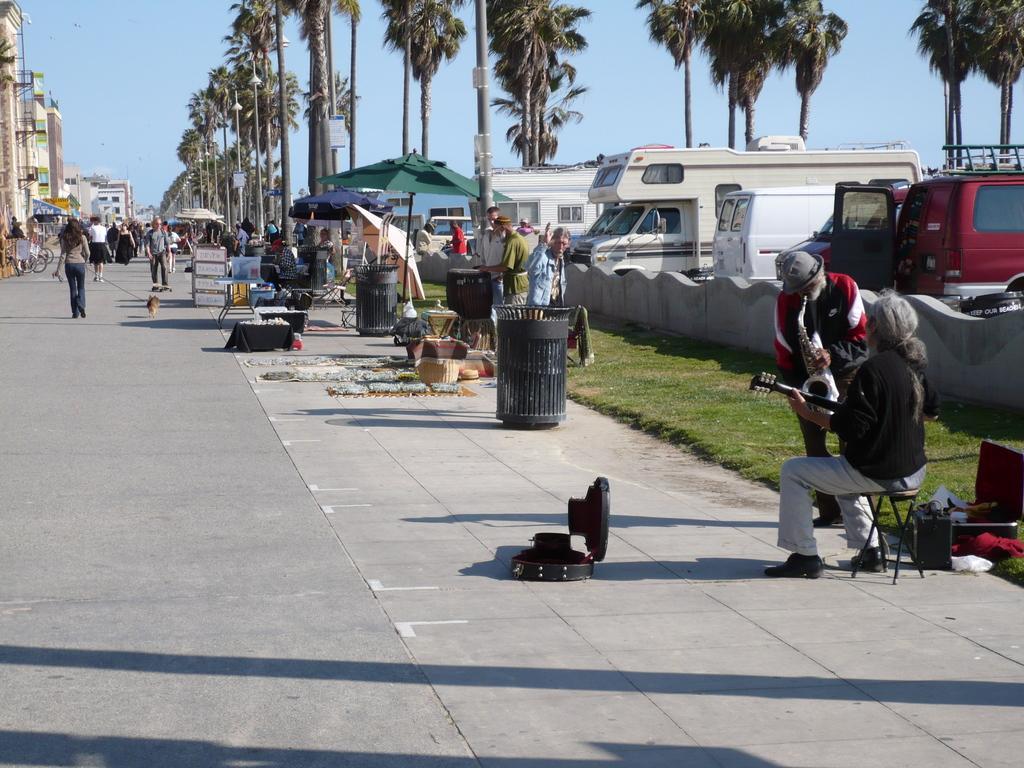Please provide a concise description of this image. In the foreground of the picture there are vehicles, people, wall, grass, dustbin, stool, umbrella, baskets, road and various objects. In the middle of the picture there are trees, buildings, people walking down the road and other objects. At the top it is sky. 